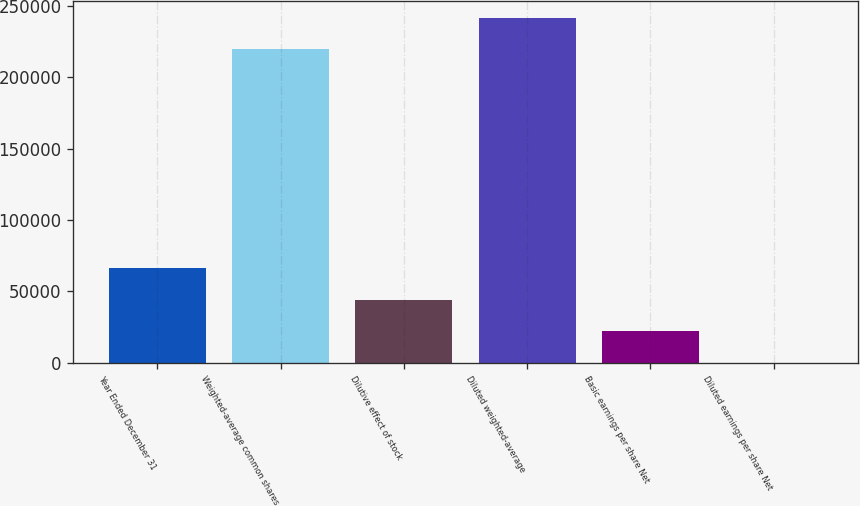<chart> <loc_0><loc_0><loc_500><loc_500><bar_chart><fcel>Year Ended December 31<fcel>Weighted-average common shares<fcel>Dilutive effect of stock<fcel>Diluted weighted-average<fcel>Basic earnings per share Net<fcel>Diluted earnings per share Net<nl><fcel>66283.8<fcel>219638<fcel>44189.9<fcel>241732<fcel>22096<fcel>2.14<nl></chart> 